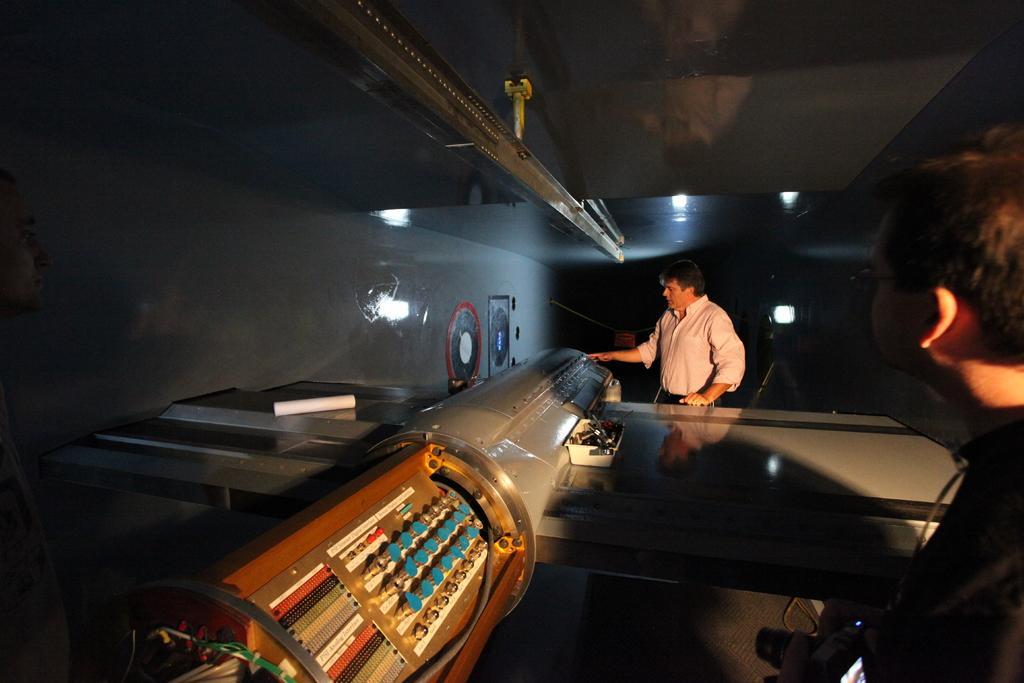Could you give a brief overview of what you see in this image? There is an electrical machine in the middle of this image, and there are two persons standing on the right side of this image and there is a wall in the background. 